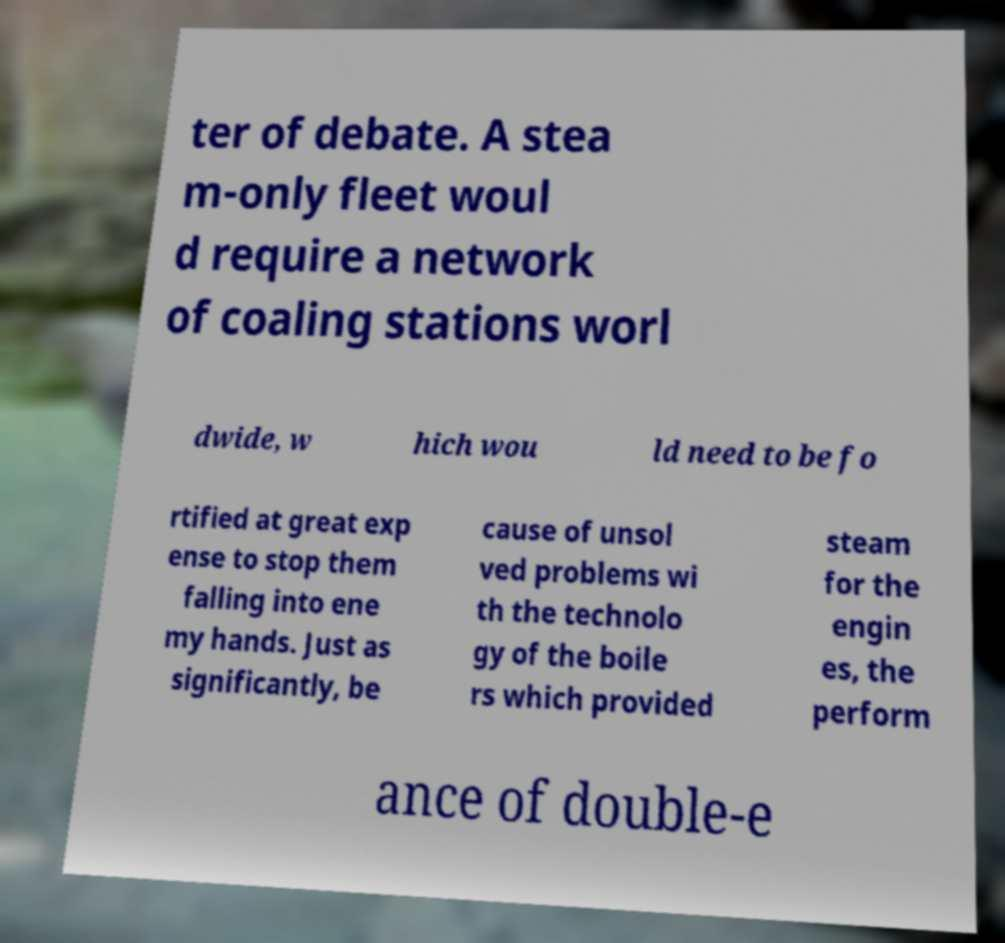What messages or text are displayed in this image? I need them in a readable, typed format. ter of debate. A stea m-only fleet woul d require a network of coaling stations worl dwide, w hich wou ld need to be fo rtified at great exp ense to stop them falling into ene my hands. Just as significantly, be cause of unsol ved problems wi th the technolo gy of the boile rs which provided steam for the engin es, the perform ance of double-e 